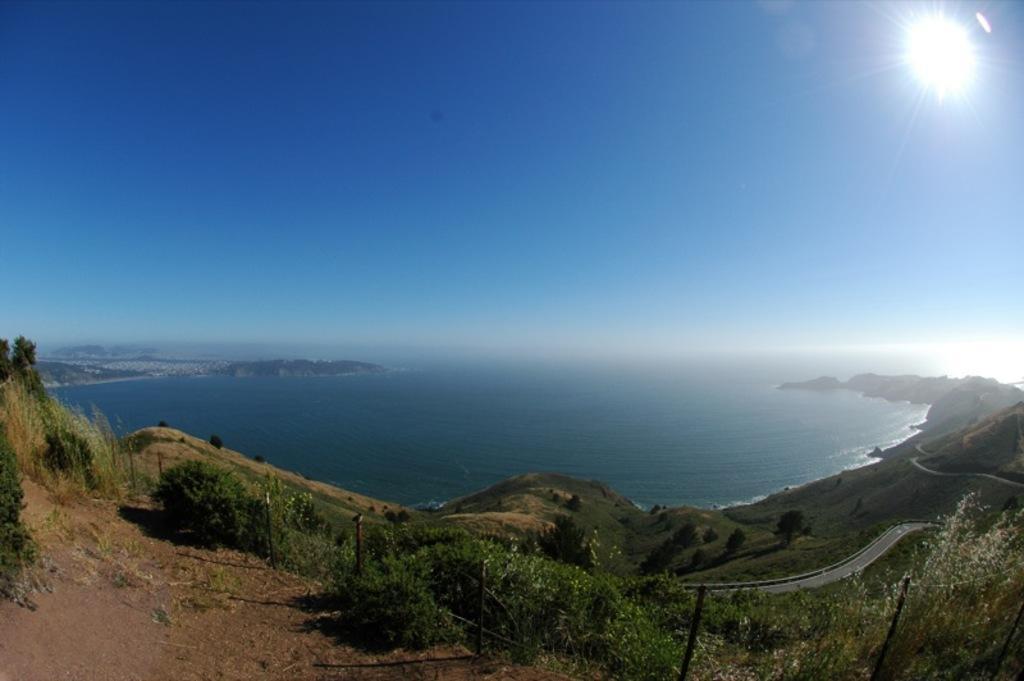In one or two sentences, can you explain what this image depicts? This image consists of an ocean. At the bottom, there are plants on the ground. To the top, there is sky in blue color. 